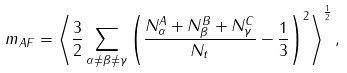<formula> <loc_0><loc_0><loc_500><loc_500>m _ { A F } = \left \langle \frac { 3 } { 2 } \sum _ { \alpha \neq \beta \neq \gamma } \left ( \frac { N _ { \alpha } ^ { A } + N _ { \beta } ^ { B } + N _ { \gamma } ^ { C } } { N _ { t } } - \frac { 1 } { 3 } \right ) ^ { 2 } \right \rangle ^ { \frac { 1 } { 2 } } ,</formula> 